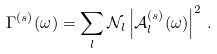<formula> <loc_0><loc_0><loc_500><loc_500>\Gamma ^ { ( s ) } ( \omega ) = \sum _ { l } \mathcal { N } _ { l } \left | \mathcal { A } _ { l } ^ { ( s ) } ( \omega ) \right | ^ { 2 } \, .</formula> 